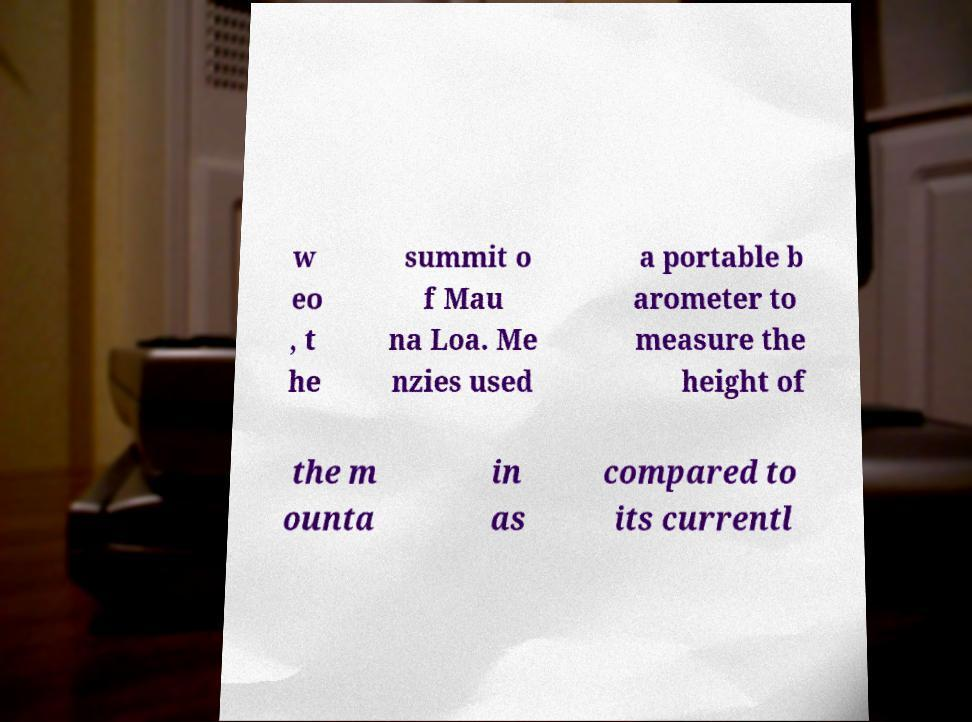Could you extract and type out the text from this image? w eo , t he summit o f Mau na Loa. Me nzies used a portable b arometer to measure the height of the m ounta in as compared to its currentl 